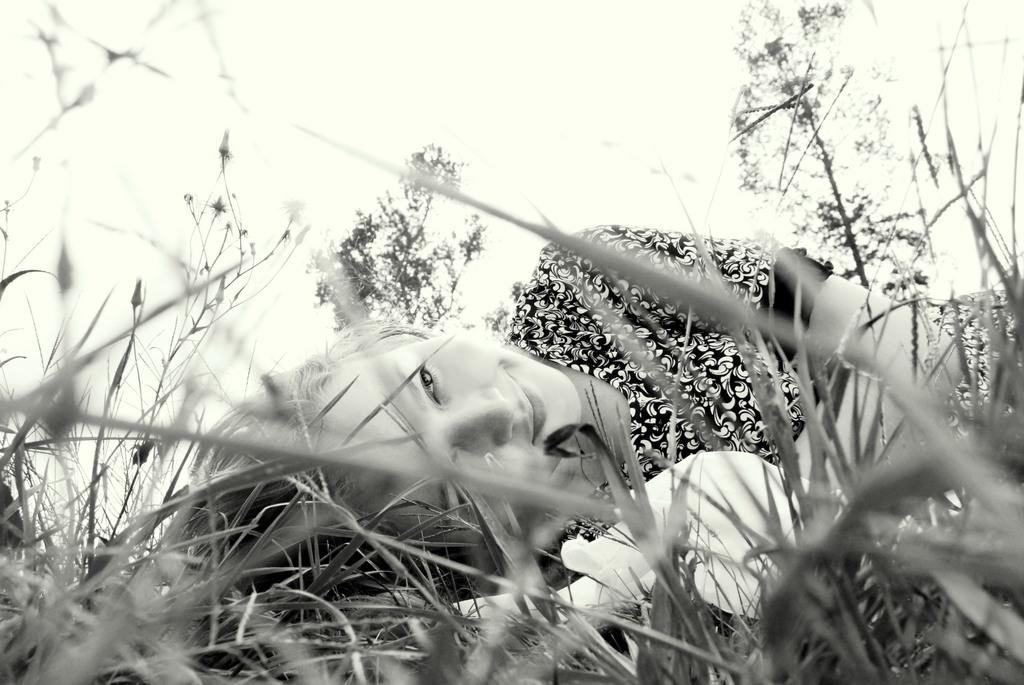What is the girl doing in the image? The girl is laying in the image. What type of surface is the girl laying on? There is grass at the bottom of the image, which suggests the girl is laying on the grass. What can be seen in the background of the image? There are trees in the background of the image. What is the color scheme of the image? The image is black and white. What is the ghost doing in the image? There is no ghost present in the image. What is the girl's tendency in the image? The facts provided do not give information about the girl's tendency, so we cannot answer this question. 